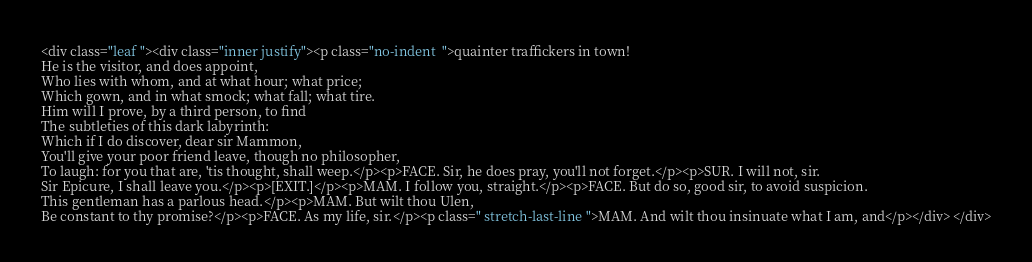<code> <loc_0><loc_0><loc_500><loc_500><_HTML_><div class="leaf "><div class="inner justify"><p class="no-indent  ">quainter traffickers in town!
He is the visitor, and does appoint,
Who lies with whom, and at what hour; what price;
Which gown, and in what smock; what fall; what tire.
Him will I prove, by a third person, to find
The subtleties of this dark labyrinth:
Which if I do discover, dear sir Mammon,
You'll give your poor friend leave, though no philosopher,
To laugh: for you that are, 'tis thought, shall weep.</p><p>FACE. Sir, he does pray, you'll not forget.</p><p>SUR. I will not, sir.
Sir Epicure, I shall leave you.</p><p>[EXIT.]</p><p>MAM. I follow you, straight.</p><p>FACE. But do so, good sir, to avoid suspicion.
This gentleman has a parlous head.</p><p>MAM. But wilt thou Ulen,
Be constant to thy promise?</p><p>FACE. As my life, sir.</p><p class=" stretch-last-line ">MAM. And wilt thou insinuate what I am, and</p></div> </div></code> 